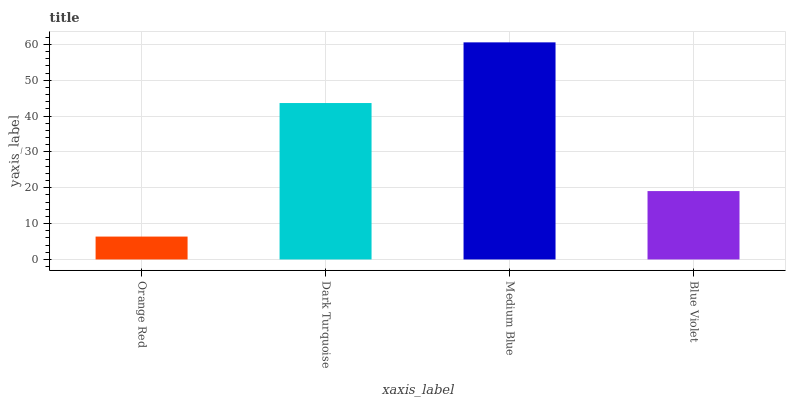Is Dark Turquoise the minimum?
Answer yes or no. No. Is Dark Turquoise the maximum?
Answer yes or no. No. Is Dark Turquoise greater than Orange Red?
Answer yes or no. Yes. Is Orange Red less than Dark Turquoise?
Answer yes or no. Yes. Is Orange Red greater than Dark Turquoise?
Answer yes or no. No. Is Dark Turquoise less than Orange Red?
Answer yes or no. No. Is Dark Turquoise the high median?
Answer yes or no. Yes. Is Blue Violet the low median?
Answer yes or no. Yes. Is Orange Red the high median?
Answer yes or no. No. Is Dark Turquoise the low median?
Answer yes or no. No. 